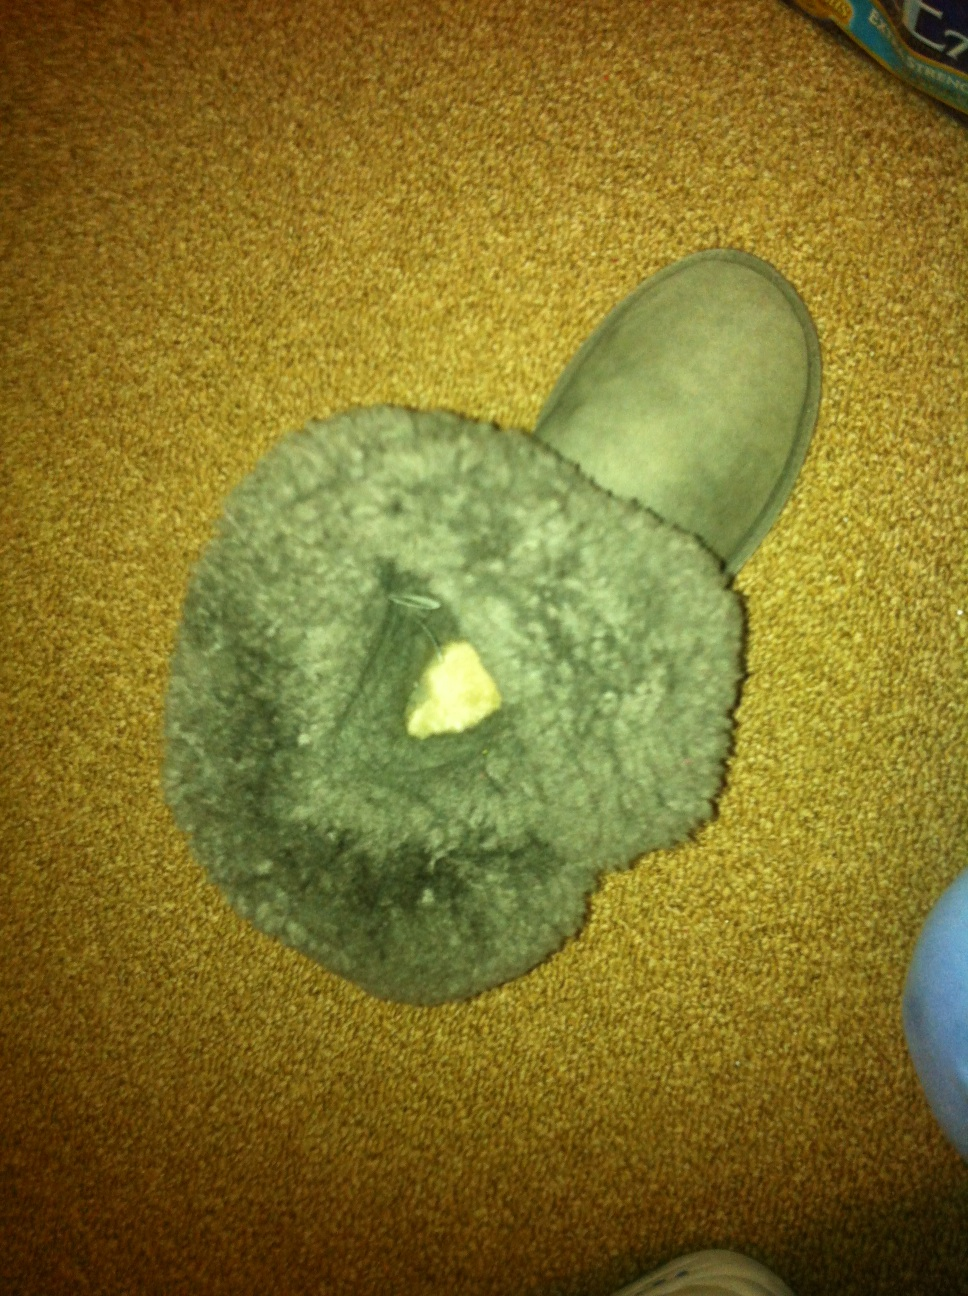Does this boot remind you of any fictional characters or stories? Absolutely! This boot has a warm, cozy look that reminds me of the boots worn by dwarves in fantasy stories, like in 'The Hobbit' or 'The Lord of the Rings'. These characters often traverse rugged terrains, and such sturdy, fur-lined boots would be perfect for their adventures! Ah, that’s interesting! Can you tell me a short imaginative story featuring a dwarf and this boot? Once upon a snowy mountain, a brave dwarf named Thrain found a peculiar boot amidst the glistening frost. Its fur lining was warm to the touch despite the harsh cold. Thrain slipped it on, feeling an immediate sense of coziness, but as he took his first step, the boot shimmered and began to glow faintly. Suddenly, Thrain found himself transported to a hidden cavern adorned with ancient jewels and gold. The boot guided him through the treasures, leading him to a mystical hammer that once belonged to his ancestors. Realizing its significance, Thrain knew that the boot had chosen him for a greater destiny, to protect his clan and their treasured history. With the enchanted boot and hammer, Thrain set out on a new journey to defend his people from impending darkness. Wow, that was an amazing story! Do you think there could be a hidden compartment in this boot where treasures or secrets might be kept? It's entirely possible! Boots, especially those with a luxurious lining, could hide a small compartment where valuables or secret messages could be stashed away. Checking the inner seams or beneath the fur padding might reveal such hidden features. In tales and legends, boots often served dual purposes, both for wear and for the safe-keeping of small, precious items. 